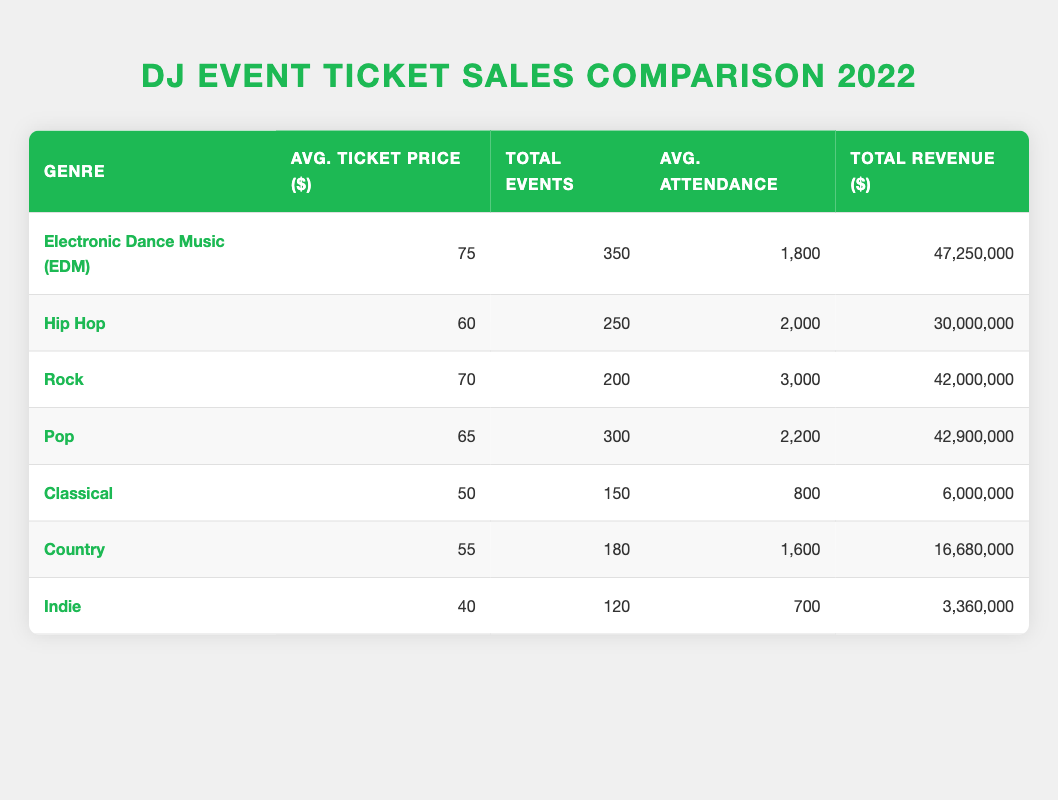What is the average ticket price for Electronic Dance Music (EDM) events? The table indicates that the average ticket price for EDM is listed directly under the "Avg. Ticket Price ($)" column, which is 75.
Answer: 75 How many total events were held for Hip Hop music in 2022? The table shows the total number of Hip Hop events in the "Total Events" column, which is 250.
Answer: 250 Which genre had the highest average attendance? By comparing the "Average Attendance" column, Rock has the highest average attendance at 3000.
Answer: Rock What is the total revenue generated from all Electronic Dance Music (EDM) events? Looking at the "Total Revenue ($)" column for EDM, it is 47,250,000.
Answer: 47,250,000 What is the average ticket price difference between Pop and Classical music? The average ticket prices for Pop and Classical are 65 and 50, respectively. The difference is calculated as 65 - 50 = 15.
Answer: 15 Did Country music events have higher total revenue than Indie music events in 2022? The table shows total revenue for Country as 16,680,000 and Indie as 3,360,000. Since 16,680,000 is greater than 3,360,000, the answer is yes.
Answer: Yes What is the total average attendance across all genres listed? To find the total average attendance, sum the average attendance of each genre: (1800 + 2000 + 3000 + 2200 + 800 + 1600 + 700) = 13,100. Then divide by the number of genres (7): 13,100 / 7 ≈ 1,871.43.
Answer: Approximately 1,871.43 Which genre generated the least total revenue? By examining the "Total Revenue ($)" column, Indie music had the lowest total revenue at 3,360,000.
Answer: Indie How many more events were held for EDM compared to Country music? The total events for EDM is 350 and for Country it is 180. The difference is 350 - 180 = 170.
Answer: 170 Is the average ticket price for Rock higher than for Pop? The average ticket price for Rock is 70 and for Pop is 65. Since 70 is greater than 65, the answer is yes.
Answer: Yes 